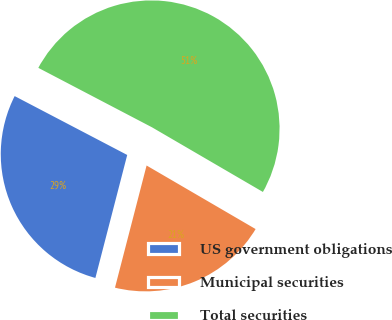<chart> <loc_0><loc_0><loc_500><loc_500><pie_chart><fcel>US government obligations<fcel>Municipal securities<fcel>Total securities<nl><fcel>28.64%<fcel>20.63%<fcel>50.73%<nl></chart> 